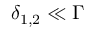Convert formula to latex. <formula><loc_0><loc_0><loc_500><loc_500>\delta _ { 1 , 2 } \ll \Gamma</formula> 